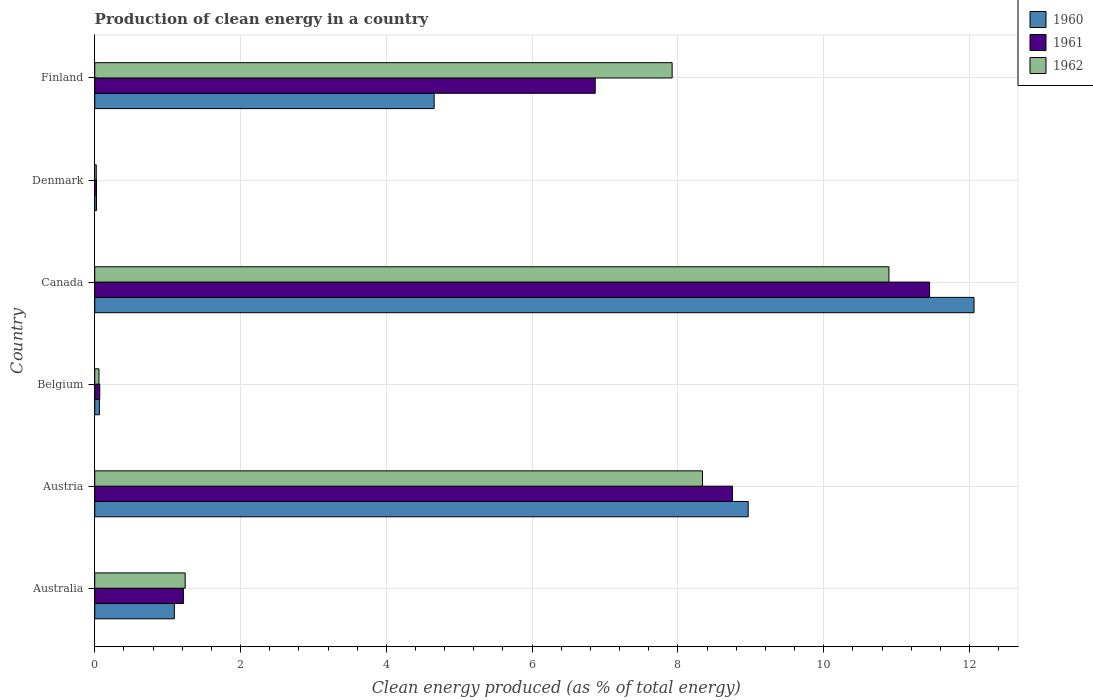Are the number of bars per tick equal to the number of legend labels?
Your answer should be very brief. Yes. How many bars are there on the 1st tick from the top?
Your answer should be compact. 3. How many bars are there on the 1st tick from the bottom?
Your response must be concise. 3. What is the percentage of clean energy produced in 1961 in Austria?
Keep it short and to the point. 8.75. Across all countries, what is the maximum percentage of clean energy produced in 1961?
Provide a short and direct response. 11.45. Across all countries, what is the minimum percentage of clean energy produced in 1962?
Offer a very short reply. 0.02. In which country was the percentage of clean energy produced in 1962 maximum?
Give a very brief answer. Canada. In which country was the percentage of clean energy produced in 1961 minimum?
Offer a terse response. Denmark. What is the total percentage of clean energy produced in 1962 in the graph?
Give a very brief answer. 28.47. What is the difference between the percentage of clean energy produced in 1960 in Belgium and that in Denmark?
Ensure brevity in your answer.  0.04. What is the difference between the percentage of clean energy produced in 1962 in Denmark and the percentage of clean energy produced in 1960 in Austria?
Give a very brief answer. -8.94. What is the average percentage of clean energy produced in 1960 per country?
Provide a short and direct response. 4.48. What is the difference between the percentage of clean energy produced in 1960 and percentage of clean energy produced in 1961 in Denmark?
Provide a short and direct response. 0. In how many countries, is the percentage of clean energy produced in 1961 greater than 0.4 %?
Your answer should be compact. 4. What is the ratio of the percentage of clean energy produced in 1961 in Belgium to that in Canada?
Make the answer very short. 0.01. Is the difference between the percentage of clean energy produced in 1960 in Belgium and Denmark greater than the difference between the percentage of clean energy produced in 1961 in Belgium and Denmark?
Provide a short and direct response. No. What is the difference between the highest and the second highest percentage of clean energy produced in 1962?
Make the answer very short. 2.56. What is the difference between the highest and the lowest percentage of clean energy produced in 1960?
Provide a short and direct response. 12.04. In how many countries, is the percentage of clean energy produced in 1961 greater than the average percentage of clean energy produced in 1961 taken over all countries?
Your answer should be very brief. 3. Is the sum of the percentage of clean energy produced in 1960 in Austria and Belgium greater than the maximum percentage of clean energy produced in 1961 across all countries?
Provide a succinct answer. No. How many countries are there in the graph?
Give a very brief answer. 6. What is the difference between two consecutive major ticks on the X-axis?
Your answer should be compact. 2. Does the graph contain any zero values?
Your answer should be very brief. No. Where does the legend appear in the graph?
Your answer should be very brief. Top right. How are the legend labels stacked?
Provide a short and direct response. Vertical. What is the title of the graph?
Offer a terse response. Production of clean energy in a country. Does "1969" appear as one of the legend labels in the graph?
Ensure brevity in your answer.  No. What is the label or title of the X-axis?
Provide a succinct answer. Clean energy produced (as % of total energy). What is the label or title of the Y-axis?
Provide a succinct answer. Country. What is the Clean energy produced (as % of total energy) in 1960 in Australia?
Your answer should be compact. 1.09. What is the Clean energy produced (as % of total energy) in 1961 in Australia?
Offer a terse response. 1.22. What is the Clean energy produced (as % of total energy) of 1962 in Australia?
Your response must be concise. 1.24. What is the Clean energy produced (as % of total energy) in 1960 in Austria?
Keep it short and to the point. 8.96. What is the Clean energy produced (as % of total energy) in 1961 in Austria?
Ensure brevity in your answer.  8.75. What is the Clean energy produced (as % of total energy) in 1962 in Austria?
Offer a terse response. 8.34. What is the Clean energy produced (as % of total energy) of 1960 in Belgium?
Your answer should be compact. 0.06. What is the Clean energy produced (as % of total energy) in 1961 in Belgium?
Keep it short and to the point. 0.07. What is the Clean energy produced (as % of total energy) of 1962 in Belgium?
Ensure brevity in your answer.  0.06. What is the Clean energy produced (as % of total energy) in 1960 in Canada?
Keep it short and to the point. 12.06. What is the Clean energy produced (as % of total energy) in 1961 in Canada?
Your answer should be compact. 11.45. What is the Clean energy produced (as % of total energy) in 1962 in Canada?
Your answer should be compact. 10.89. What is the Clean energy produced (as % of total energy) in 1960 in Denmark?
Make the answer very short. 0.02. What is the Clean energy produced (as % of total energy) in 1961 in Denmark?
Keep it short and to the point. 0.02. What is the Clean energy produced (as % of total energy) of 1962 in Denmark?
Provide a succinct answer. 0.02. What is the Clean energy produced (as % of total energy) of 1960 in Finland?
Offer a terse response. 4.66. What is the Clean energy produced (as % of total energy) in 1961 in Finland?
Offer a terse response. 6.87. What is the Clean energy produced (as % of total energy) in 1962 in Finland?
Make the answer very short. 7.92. Across all countries, what is the maximum Clean energy produced (as % of total energy) of 1960?
Offer a terse response. 12.06. Across all countries, what is the maximum Clean energy produced (as % of total energy) of 1961?
Give a very brief answer. 11.45. Across all countries, what is the maximum Clean energy produced (as % of total energy) in 1962?
Your answer should be very brief. 10.89. Across all countries, what is the minimum Clean energy produced (as % of total energy) in 1960?
Make the answer very short. 0.02. Across all countries, what is the minimum Clean energy produced (as % of total energy) of 1961?
Your answer should be compact. 0.02. Across all countries, what is the minimum Clean energy produced (as % of total energy) in 1962?
Provide a short and direct response. 0.02. What is the total Clean energy produced (as % of total energy) of 1960 in the graph?
Provide a short and direct response. 26.86. What is the total Clean energy produced (as % of total energy) in 1961 in the graph?
Make the answer very short. 28.38. What is the total Clean energy produced (as % of total energy) in 1962 in the graph?
Ensure brevity in your answer.  28.47. What is the difference between the Clean energy produced (as % of total energy) of 1960 in Australia and that in Austria?
Offer a very short reply. -7.87. What is the difference between the Clean energy produced (as % of total energy) in 1961 in Australia and that in Austria?
Offer a very short reply. -7.53. What is the difference between the Clean energy produced (as % of total energy) of 1962 in Australia and that in Austria?
Offer a very short reply. -7.1. What is the difference between the Clean energy produced (as % of total energy) in 1960 in Australia and that in Belgium?
Make the answer very short. 1.03. What is the difference between the Clean energy produced (as % of total energy) in 1961 in Australia and that in Belgium?
Provide a succinct answer. 1.15. What is the difference between the Clean energy produced (as % of total energy) of 1962 in Australia and that in Belgium?
Provide a short and direct response. 1.18. What is the difference between the Clean energy produced (as % of total energy) in 1960 in Australia and that in Canada?
Your answer should be compact. -10.97. What is the difference between the Clean energy produced (as % of total energy) of 1961 in Australia and that in Canada?
Make the answer very short. -10.24. What is the difference between the Clean energy produced (as % of total energy) of 1962 in Australia and that in Canada?
Provide a short and direct response. -9.65. What is the difference between the Clean energy produced (as % of total energy) in 1960 in Australia and that in Denmark?
Make the answer very short. 1.07. What is the difference between the Clean energy produced (as % of total energy) of 1961 in Australia and that in Denmark?
Make the answer very short. 1.19. What is the difference between the Clean energy produced (as % of total energy) in 1962 in Australia and that in Denmark?
Your answer should be compact. 1.22. What is the difference between the Clean energy produced (as % of total energy) of 1960 in Australia and that in Finland?
Ensure brevity in your answer.  -3.56. What is the difference between the Clean energy produced (as % of total energy) of 1961 in Australia and that in Finland?
Offer a very short reply. -5.65. What is the difference between the Clean energy produced (as % of total energy) in 1962 in Australia and that in Finland?
Provide a succinct answer. -6.68. What is the difference between the Clean energy produced (as % of total energy) of 1960 in Austria and that in Belgium?
Your answer should be very brief. 8.9. What is the difference between the Clean energy produced (as % of total energy) in 1961 in Austria and that in Belgium?
Offer a very short reply. 8.68. What is the difference between the Clean energy produced (as % of total energy) of 1962 in Austria and that in Belgium?
Keep it short and to the point. 8.28. What is the difference between the Clean energy produced (as % of total energy) in 1960 in Austria and that in Canada?
Offer a very short reply. -3.1. What is the difference between the Clean energy produced (as % of total energy) in 1961 in Austria and that in Canada?
Keep it short and to the point. -2.7. What is the difference between the Clean energy produced (as % of total energy) in 1962 in Austria and that in Canada?
Your answer should be compact. -2.56. What is the difference between the Clean energy produced (as % of total energy) in 1960 in Austria and that in Denmark?
Offer a terse response. 8.94. What is the difference between the Clean energy produced (as % of total energy) in 1961 in Austria and that in Denmark?
Your answer should be compact. 8.72. What is the difference between the Clean energy produced (as % of total energy) in 1962 in Austria and that in Denmark?
Your answer should be very brief. 8.32. What is the difference between the Clean energy produced (as % of total energy) of 1960 in Austria and that in Finland?
Provide a succinct answer. 4.31. What is the difference between the Clean energy produced (as % of total energy) of 1961 in Austria and that in Finland?
Provide a short and direct response. 1.88. What is the difference between the Clean energy produced (as % of total energy) in 1962 in Austria and that in Finland?
Make the answer very short. 0.42. What is the difference between the Clean energy produced (as % of total energy) in 1960 in Belgium and that in Canada?
Keep it short and to the point. -12. What is the difference between the Clean energy produced (as % of total energy) in 1961 in Belgium and that in Canada?
Your answer should be very brief. -11.38. What is the difference between the Clean energy produced (as % of total energy) in 1962 in Belgium and that in Canada?
Keep it short and to the point. -10.84. What is the difference between the Clean energy produced (as % of total energy) of 1960 in Belgium and that in Denmark?
Ensure brevity in your answer.  0.04. What is the difference between the Clean energy produced (as % of total energy) in 1961 in Belgium and that in Denmark?
Keep it short and to the point. 0.04. What is the difference between the Clean energy produced (as % of total energy) in 1962 in Belgium and that in Denmark?
Your answer should be compact. 0.04. What is the difference between the Clean energy produced (as % of total energy) of 1960 in Belgium and that in Finland?
Keep it short and to the point. -4.59. What is the difference between the Clean energy produced (as % of total energy) of 1961 in Belgium and that in Finland?
Your answer should be compact. -6.8. What is the difference between the Clean energy produced (as % of total energy) of 1962 in Belgium and that in Finland?
Provide a short and direct response. -7.86. What is the difference between the Clean energy produced (as % of total energy) in 1960 in Canada and that in Denmark?
Keep it short and to the point. 12.04. What is the difference between the Clean energy produced (as % of total energy) in 1961 in Canada and that in Denmark?
Keep it short and to the point. 11.43. What is the difference between the Clean energy produced (as % of total energy) in 1962 in Canada and that in Denmark?
Keep it short and to the point. 10.87. What is the difference between the Clean energy produced (as % of total energy) of 1960 in Canada and that in Finland?
Your answer should be very brief. 7.41. What is the difference between the Clean energy produced (as % of total energy) of 1961 in Canada and that in Finland?
Your response must be concise. 4.59. What is the difference between the Clean energy produced (as % of total energy) of 1962 in Canada and that in Finland?
Your response must be concise. 2.97. What is the difference between the Clean energy produced (as % of total energy) of 1960 in Denmark and that in Finland?
Keep it short and to the point. -4.63. What is the difference between the Clean energy produced (as % of total energy) of 1961 in Denmark and that in Finland?
Your answer should be very brief. -6.84. What is the difference between the Clean energy produced (as % of total energy) in 1962 in Denmark and that in Finland?
Provide a short and direct response. -7.9. What is the difference between the Clean energy produced (as % of total energy) of 1960 in Australia and the Clean energy produced (as % of total energy) of 1961 in Austria?
Offer a terse response. -7.66. What is the difference between the Clean energy produced (as % of total energy) of 1960 in Australia and the Clean energy produced (as % of total energy) of 1962 in Austria?
Provide a short and direct response. -7.25. What is the difference between the Clean energy produced (as % of total energy) in 1961 in Australia and the Clean energy produced (as % of total energy) in 1962 in Austria?
Offer a terse response. -7.12. What is the difference between the Clean energy produced (as % of total energy) of 1960 in Australia and the Clean energy produced (as % of total energy) of 1961 in Belgium?
Keep it short and to the point. 1.02. What is the difference between the Clean energy produced (as % of total energy) in 1960 in Australia and the Clean energy produced (as % of total energy) in 1962 in Belgium?
Your answer should be very brief. 1.03. What is the difference between the Clean energy produced (as % of total energy) of 1961 in Australia and the Clean energy produced (as % of total energy) of 1962 in Belgium?
Give a very brief answer. 1.16. What is the difference between the Clean energy produced (as % of total energy) in 1960 in Australia and the Clean energy produced (as % of total energy) in 1961 in Canada?
Offer a very short reply. -10.36. What is the difference between the Clean energy produced (as % of total energy) of 1960 in Australia and the Clean energy produced (as % of total energy) of 1962 in Canada?
Your answer should be compact. -9.8. What is the difference between the Clean energy produced (as % of total energy) of 1961 in Australia and the Clean energy produced (as % of total energy) of 1962 in Canada?
Offer a terse response. -9.68. What is the difference between the Clean energy produced (as % of total energy) of 1960 in Australia and the Clean energy produced (as % of total energy) of 1961 in Denmark?
Offer a very short reply. 1.07. What is the difference between the Clean energy produced (as % of total energy) in 1960 in Australia and the Clean energy produced (as % of total energy) in 1962 in Denmark?
Make the answer very short. 1.07. What is the difference between the Clean energy produced (as % of total energy) of 1961 in Australia and the Clean energy produced (as % of total energy) of 1962 in Denmark?
Offer a very short reply. 1.2. What is the difference between the Clean energy produced (as % of total energy) in 1960 in Australia and the Clean energy produced (as % of total energy) in 1961 in Finland?
Your answer should be very brief. -5.77. What is the difference between the Clean energy produced (as % of total energy) of 1960 in Australia and the Clean energy produced (as % of total energy) of 1962 in Finland?
Offer a terse response. -6.83. What is the difference between the Clean energy produced (as % of total energy) of 1961 in Australia and the Clean energy produced (as % of total energy) of 1962 in Finland?
Give a very brief answer. -6.7. What is the difference between the Clean energy produced (as % of total energy) of 1960 in Austria and the Clean energy produced (as % of total energy) of 1961 in Belgium?
Offer a very short reply. 8.9. What is the difference between the Clean energy produced (as % of total energy) of 1960 in Austria and the Clean energy produced (as % of total energy) of 1962 in Belgium?
Your answer should be very brief. 8.91. What is the difference between the Clean energy produced (as % of total energy) of 1961 in Austria and the Clean energy produced (as % of total energy) of 1962 in Belgium?
Provide a succinct answer. 8.69. What is the difference between the Clean energy produced (as % of total energy) of 1960 in Austria and the Clean energy produced (as % of total energy) of 1961 in Canada?
Your answer should be compact. -2.49. What is the difference between the Clean energy produced (as % of total energy) of 1960 in Austria and the Clean energy produced (as % of total energy) of 1962 in Canada?
Your answer should be compact. -1.93. What is the difference between the Clean energy produced (as % of total energy) in 1961 in Austria and the Clean energy produced (as % of total energy) in 1962 in Canada?
Your response must be concise. -2.15. What is the difference between the Clean energy produced (as % of total energy) in 1960 in Austria and the Clean energy produced (as % of total energy) in 1961 in Denmark?
Provide a short and direct response. 8.94. What is the difference between the Clean energy produced (as % of total energy) of 1960 in Austria and the Clean energy produced (as % of total energy) of 1962 in Denmark?
Offer a very short reply. 8.94. What is the difference between the Clean energy produced (as % of total energy) in 1961 in Austria and the Clean energy produced (as % of total energy) in 1962 in Denmark?
Offer a terse response. 8.73. What is the difference between the Clean energy produced (as % of total energy) in 1960 in Austria and the Clean energy produced (as % of total energy) in 1961 in Finland?
Keep it short and to the point. 2.1. What is the difference between the Clean energy produced (as % of total energy) of 1960 in Austria and the Clean energy produced (as % of total energy) of 1962 in Finland?
Your response must be concise. 1.04. What is the difference between the Clean energy produced (as % of total energy) of 1961 in Austria and the Clean energy produced (as % of total energy) of 1962 in Finland?
Offer a very short reply. 0.83. What is the difference between the Clean energy produced (as % of total energy) in 1960 in Belgium and the Clean energy produced (as % of total energy) in 1961 in Canada?
Offer a very short reply. -11.39. What is the difference between the Clean energy produced (as % of total energy) of 1960 in Belgium and the Clean energy produced (as % of total energy) of 1962 in Canada?
Give a very brief answer. -10.83. What is the difference between the Clean energy produced (as % of total energy) of 1961 in Belgium and the Clean energy produced (as % of total energy) of 1962 in Canada?
Offer a very short reply. -10.83. What is the difference between the Clean energy produced (as % of total energy) of 1960 in Belgium and the Clean energy produced (as % of total energy) of 1961 in Denmark?
Your answer should be compact. 0.04. What is the difference between the Clean energy produced (as % of total energy) in 1960 in Belgium and the Clean energy produced (as % of total energy) in 1962 in Denmark?
Give a very brief answer. 0.04. What is the difference between the Clean energy produced (as % of total energy) in 1961 in Belgium and the Clean energy produced (as % of total energy) in 1962 in Denmark?
Your answer should be very brief. 0.05. What is the difference between the Clean energy produced (as % of total energy) of 1960 in Belgium and the Clean energy produced (as % of total energy) of 1961 in Finland?
Make the answer very short. -6.8. What is the difference between the Clean energy produced (as % of total energy) of 1960 in Belgium and the Clean energy produced (as % of total energy) of 1962 in Finland?
Your response must be concise. -7.86. What is the difference between the Clean energy produced (as % of total energy) of 1961 in Belgium and the Clean energy produced (as % of total energy) of 1962 in Finland?
Provide a succinct answer. -7.85. What is the difference between the Clean energy produced (as % of total energy) in 1960 in Canada and the Clean energy produced (as % of total energy) in 1961 in Denmark?
Make the answer very short. 12.04. What is the difference between the Clean energy produced (as % of total energy) in 1960 in Canada and the Clean energy produced (as % of total energy) in 1962 in Denmark?
Give a very brief answer. 12.04. What is the difference between the Clean energy produced (as % of total energy) of 1961 in Canada and the Clean energy produced (as % of total energy) of 1962 in Denmark?
Your answer should be very brief. 11.43. What is the difference between the Clean energy produced (as % of total energy) in 1960 in Canada and the Clean energy produced (as % of total energy) in 1961 in Finland?
Give a very brief answer. 5.2. What is the difference between the Clean energy produced (as % of total energy) of 1960 in Canada and the Clean energy produced (as % of total energy) of 1962 in Finland?
Your answer should be very brief. 4.14. What is the difference between the Clean energy produced (as % of total energy) of 1961 in Canada and the Clean energy produced (as % of total energy) of 1962 in Finland?
Your answer should be very brief. 3.53. What is the difference between the Clean energy produced (as % of total energy) of 1960 in Denmark and the Clean energy produced (as % of total energy) of 1961 in Finland?
Your answer should be very brief. -6.84. What is the difference between the Clean energy produced (as % of total energy) of 1960 in Denmark and the Clean energy produced (as % of total energy) of 1962 in Finland?
Ensure brevity in your answer.  -7.9. What is the difference between the Clean energy produced (as % of total energy) in 1961 in Denmark and the Clean energy produced (as % of total energy) in 1962 in Finland?
Provide a succinct answer. -7.9. What is the average Clean energy produced (as % of total energy) in 1960 per country?
Give a very brief answer. 4.48. What is the average Clean energy produced (as % of total energy) of 1961 per country?
Ensure brevity in your answer.  4.73. What is the average Clean energy produced (as % of total energy) in 1962 per country?
Offer a terse response. 4.75. What is the difference between the Clean energy produced (as % of total energy) of 1960 and Clean energy produced (as % of total energy) of 1961 in Australia?
Provide a short and direct response. -0.12. What is the difference between the Clean energy produced (as % of total energy) of 1960 and Clean energy produced (as % of total energy) of 1962 in Australia?
Make the answer very short. -0.15. What is the difference between the Clean energy produced (as % of total energy) in 1961 and Clean energy produced (as % of total energy) in 1962 in Australia?
Your response must be concise. -0.02. What is the difference between the Clean energy produced (as % of total energy) in 1960 and Clean energy produced (as % of total energy) in 1961 in Austria?
Your answer should be very brief. 0.22. What is the difference between the Clean energy produced (as % of total energy) of 1960 and Clean energy produced (as % of total energy) of 1962 in Austria?
Your answer should be very brief. 0.63. What is the difference between the Clean energy produced (as % of total energy) of 1961 and Clean energy produced (as % of total energy) of 1962 in Austria?
Make the answer very short. 0.41. What is the difference between the Clean energy produced (as % of total energy) in 1960 and Clean energy produced (as % of total energy) in 1961 in Belgium?
Your answer should be very brief. -0. What is the difference between the Clean energy produced (as % of total energy) of 1960 and Clean energy produced (as % of total energy) of 1962 in Belgium?
Keep it short and to the point. 0.01. What is the difference between the Clean energy produced (as % of total energy) in 1961 and Clean energy produced (as % of total energy) in 1962 in Belgium?
Offer a terse response. 0.01. What is the difference between the Clean energy produced (as % of total energy) in 1960 and Clean energy produced (as % of total energy) in 1961 in Canada?
Ensure brevity in your answer.  0.61. What is the difference between the Clean energy produced (as % of total energy) of 1960 and Clean energy produced (as % of total energy) of 1962 in Canada?
Your answer should be very brief. 1.17. What is the difference between the Clean energy produced (as % of total energy) in 1961 and Clean energy produced (as % of total energy) in 1962 in Canada?
Offer a terse response. 0.56. What is the difference between the Clean energy produced (as % of total energy) in 1960 and Clean energy produced (as % of total energy) in 1961 in Denmark?
Your answer should be very brief. 0. What is the difference between the Clean energy produced (as % of total energy) of 1960 and Clean energy produced (as % of total energy) of 1962 in Denmark?
Make the answer very short. 0. What is the difference between the Clean energy produced (as % of total energy) in 1961 and Clean energy produced (as % of total energy) in 1962 in Denmark?
Your response must be concise. 0. What is the difference between the Clean energy produced (as % of total energy) of 1960 and Clean energy produced (as % of total energy) of 1961 in Finland?
Your answer should be very brief. -2.21. What is the difference between the Clean energy produced (as % of total energy) in 1960 and Clean energy produced (as % of total energy) in 1962 in Finland?
Your answer should be compact. -3.26. What is the difference between the Clean energy produced (as % of total energy) in 1961 and Clean energy produced (as % of total energy) in 1962 in Finland?
Ensure brevity in your answer.  -1.06. What is the ratio of the Clean energy produced (as % of total energy) in 1960 in Australia to that in Austria?
Keep it short and to the point. 0.12. What is the ratio of the Clean energy produced (as % of total energy) of 1961 in Australia to that in Austria?
Keep it short and to the point. 0.14. What is the ratio of the Clean energy produced (as % of total energy) in 1962 in Australia to that in Austria?
Offer a very short reply. 0.15. What is the ratio of the Clean energy produced (as % of total energy) of 1960 in Australia to that in Belgium?
Your answer should be very brief. 17.03. What is the ratio of the Clean energy produced (as % of total energy) in 1961 in Australia to that in Belgium?
Keep it short and to the point. 17.67. What is the ratio of the Clean energy produced (as % of total energy) of 1962 in Australia to that in Belgium?
Offer a very short reply. 21.34. What is the ratio of the Clean energy produced (as % of total energy) in 1960 in Australia to that in Canada?
Offer a very short reply. 0.09. What is the ratio of the Clean energy produced (as % of total energy) in 1961 in Australia to that in Canada?
Give a very brief answer. 0.11. What is the ratio of the Clean energy produced (as % of total energy) of 1962 in Australia to that in Canada?
Offer a very short reply. 0.11. What is the ratio of the Clean energy produced (as % of total energy) in 1960 in Australia to that in Denmark?
Give a very brief answer. 44.73. What is the ratio of the Clean energy produced (as % of total energy) of 1961 in Australia to that in Denmark?
Make the answer very short. 50.77. What is the ratio of the Clean energy produced (as % of total energy) in 1962 in Australia to that in Denmark?
Ensure brevity in your answer.  59.22. What is the ratio of the Clean energy produced (as % of total energy) of 1960 in Australia to that in Finland?
Make the answer very short. 0.23. What is the ratio of the Clean energy produced (as % of total energy) of 1961 in Australia to that in Finland?
Provide a succinct answer. 0.18. What is the ratio of the Clean energy produced (as % of total energy) in 1962 in Australia to that in Finland?
Provide a succinct answer. 0.16. What is the ratio of the Clean energy produced (as % of total energy) of 1960 in Austria to that in Belgium?
Your answer should be compact. 139.76. What is the ratio of the Clean energy produced (as % of total energy) in 1961 in Austria to that in Belgium?
Your answer should be compact. 127.07. What is the ratio of the Clean energy produced (as % of total energy) in 1962 in Austria to that in Belgium?
Your answer should be compact. 143.44. What is the ratio of the Clean energy produced (as % of total energy) in 1960 in Austria to that in Canada?
Keep it short and to the point. 0.74. What is the ratio of the Clean energy produced (as % of total energy) in 1961 in Austria to that in Canada?
Offer a terse response. 0.76. What is the ratio of the Clean energy produced (as % of total energy) of 1962 in Austria to that in Canada?
Keep it short and to the point. 0.77. What is the ratio of the Clean energy produced (as % of total energy) in 1960 in Austria to that in Denmark?
Make the answer very short. 367.18. What is the ratio of the Clean energy produced (as % of total energy) of 1961 in Austria to that in Denmark?
Provide a short and direct response. 365.06. What is the ratio of the Clean energy produced (as % of total energy) in 1962 in Austria to that in Denmark?
Your response must be concise. 397.95. What is the ratio of the Clean energy produced (as % of total energy) in 1960 in Austria to that in Finland?
Your response must be concise. 1.93. What is the ratio of the Clean energy produced (as % of total energy) in 1961 in Austria to that in Finland?
Your answer should be compact. 1.27. What is the ratio of the Clean energy produced (as % of total energy) of 1962 in Austria to that in Finland?
Offer a very short reply. 1.05. What is the ratio of the Clean energy produced (as % of total energy) in 1960 in Belgium to that in Canada?
Provide a succinct answer. 0.01. What is the ratio of the Clean energy produced (as % of total energy) of 1961 in Belgium to that in Canada?
Give a very brief answer. 0.01. What is the ratio of the Clean energy produced (as % of total energy) in 1962 in Belgium to that in Canada?
Your answer should be compact. 0.01. What is the ratio of the Clean energy produced (as % of total energy) of 1960 in Belgium to that in Denmark?
Your answer should be very brief. 2.63. What is the ratio of the Clean energy produced (as % of total energy) of 1961 in Belgium to that in Denmark?
Offer a terse response. 2.87. What is the ratio of the Clean energy produced (as % of total energy) of 1962 in Belgium to that in Denmark?
Offer a terse response. 2.77. What is the ratio of the Clean energy produced (as % of total energy) in 1960 in Belgium to that in Finland?
Keep it short and to the point. 0.01. What is the ratio of the Clean energy produced (as % of total energy) in 1962 in Belgium to that in Finland?
Provide a succinct answer. 0.01. What is the ratio of the Clean energy produced (as % of total energy) of 1960 in Canada to that in Denmark?
Offer a terse response. 494.07. What is the ratio of the Clean energy produced (as % of total energy) of 1961 in Canada to that in Denmark?
Ensure brevity in your answer.  477.92. What is the ratio of the Clean energy produced (as % of total energy) of 1962 in Canada to that in Denmark?
Give a very brief answer. 520.01. What is the ratio of the Clean energy produced (as % of total energy) of 1960 in Canada to that in Finland?
Give a very brief answer. 2.59. What is the ratio of the Clean energy produced (as % of total energy) in 1961 in Canada to that in Finland?
Offer a terse response. 1.67. What is the ratio of the Clean energy produced (as % of total energy) in 1962 in Canada to that in Finland?
Provide a succinct answer. 1.38. What is the ratio of the Clean energy produced (as % of total energy) in 1960 in Denmark to that in Finland?
Provide a short and direct response. 0.01. What is the ratio of the Clean energy produced (as % of total energy) of 1961 in Denmark to that in Finland?
Provide a short and direct response. 0. What is the ratio of the Clean energy produced (as % of total energy) of 1962 in Denmark to that in Finland?
Make the answer very short. 0. What is the difference between the highest and the second highest Clean energy produced (as % of total energy) of 1960?
Provide a short and direct response. 3.1. What is the difference between the highest and the second highest Clean energy produced (as % of total energy) of 1961?
Offer a very short reply. 2.7. What is the difference between the highest and the second highest Clean energy produced (as % of total energy) in 1962?
Offer a terse response. 2.56. What is the difference between the highest and the lowest Clean energy produced (as % of total energy) of 1960?
Offer a very short reply. 12.04. What is the difference between the highest and the lowest Clean energy produced (as % of total energy) of 1961?
Ensure brevity in your answer.  11.43. What is the difference between the highest and the lowest Clean energy produced (as % of total energy) of 1962?
Ensure brevity in your answer.  10.87. 